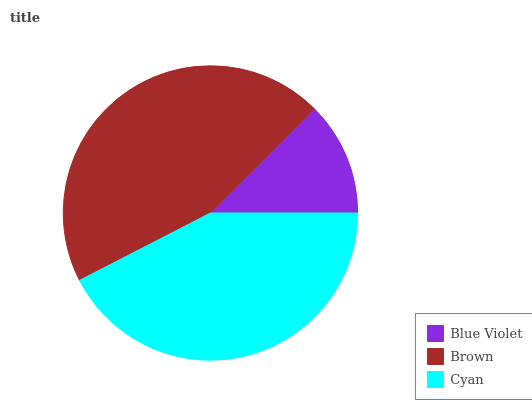Is Blue Violet the minimum?
Answer yes or no. Yes. Is Brown the maximum?
Answer yes or no. Yes. Is Cyan the minimum?
Answer yes or no. No. Is Cyan the maximum?
Answer yes or no. No. Is Brown greater than Cyan?
Answer yes or no. Yes. Is Cyan less than Brown?
Answer yes or no. Yes. Is Cyan greater than Brown?
Answer yes or no. No. Is Brown less than Cyan?
Answer yes or no. No. Is Cyan the high median?
Answer yes or no. Yes. Is Cyan the low median?
Answer yes or no. Yes. Is Blue Violet the high median?
Answer yes or no. No. Is Brown the low median?
Answer yes or no. No. 